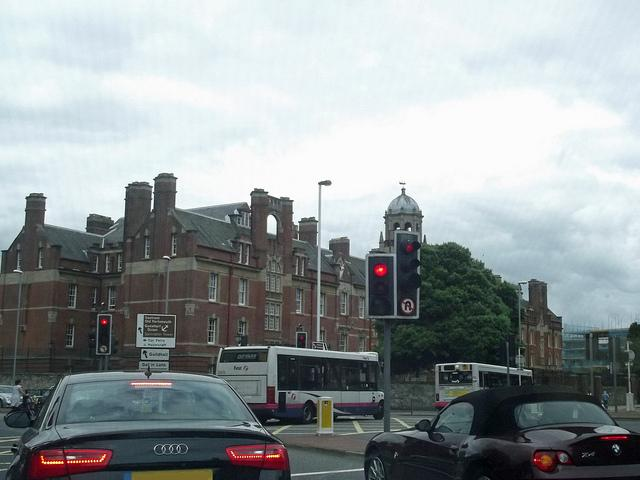What country are these cars manufactured in? germany 